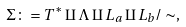<formula> <loc_0><loc_0><loc_500><loc_500>\Sigma \colon = T ^ { \ast } \amalg \Lambda \amalg L _ { a } \amalg L _ { b } / \sim ,</formula> 